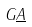<formula> <loc_0><loc_0><loc_500><loc_500>G \underline { A }</formula> 